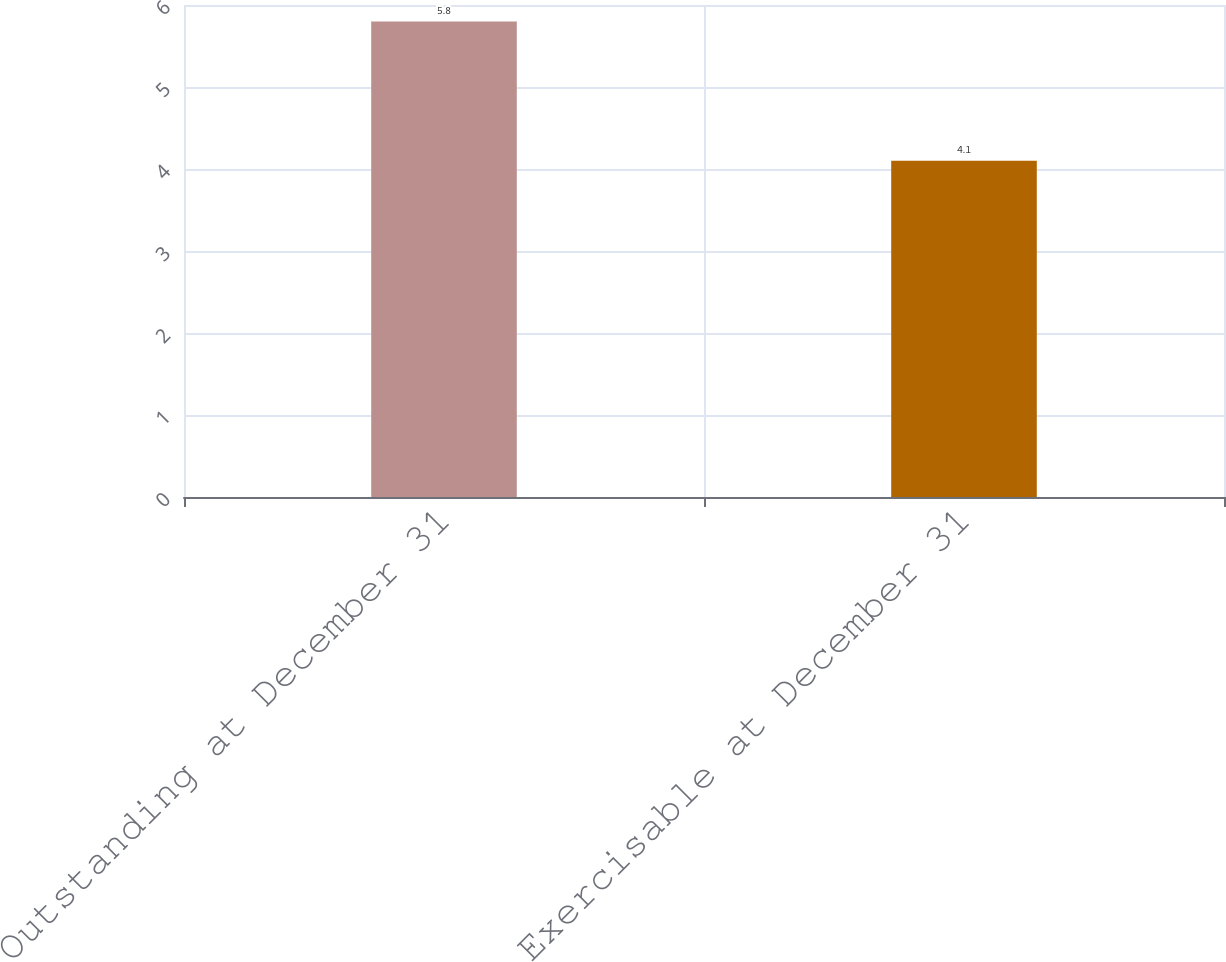Convert chart. <chart><loc_0><loc_0><loc_500><loc_500><bar_chart><fcel>Outstanding at December 31<fcel>Exercisable at December 31<nl><fcel>5.8<fcel>4.1<nl></chart> 